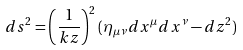<formula> <loc_0><loc_0><loc_500><loc_500>d s ^ { 2 } = \left ( \frac { 1 } { k z } \right ) ^ { 2 } ( \eta _ { \mu \nu } d x ^ { \mu } d x ^ { \nu } - d z ^ { 2 } )</formula> 